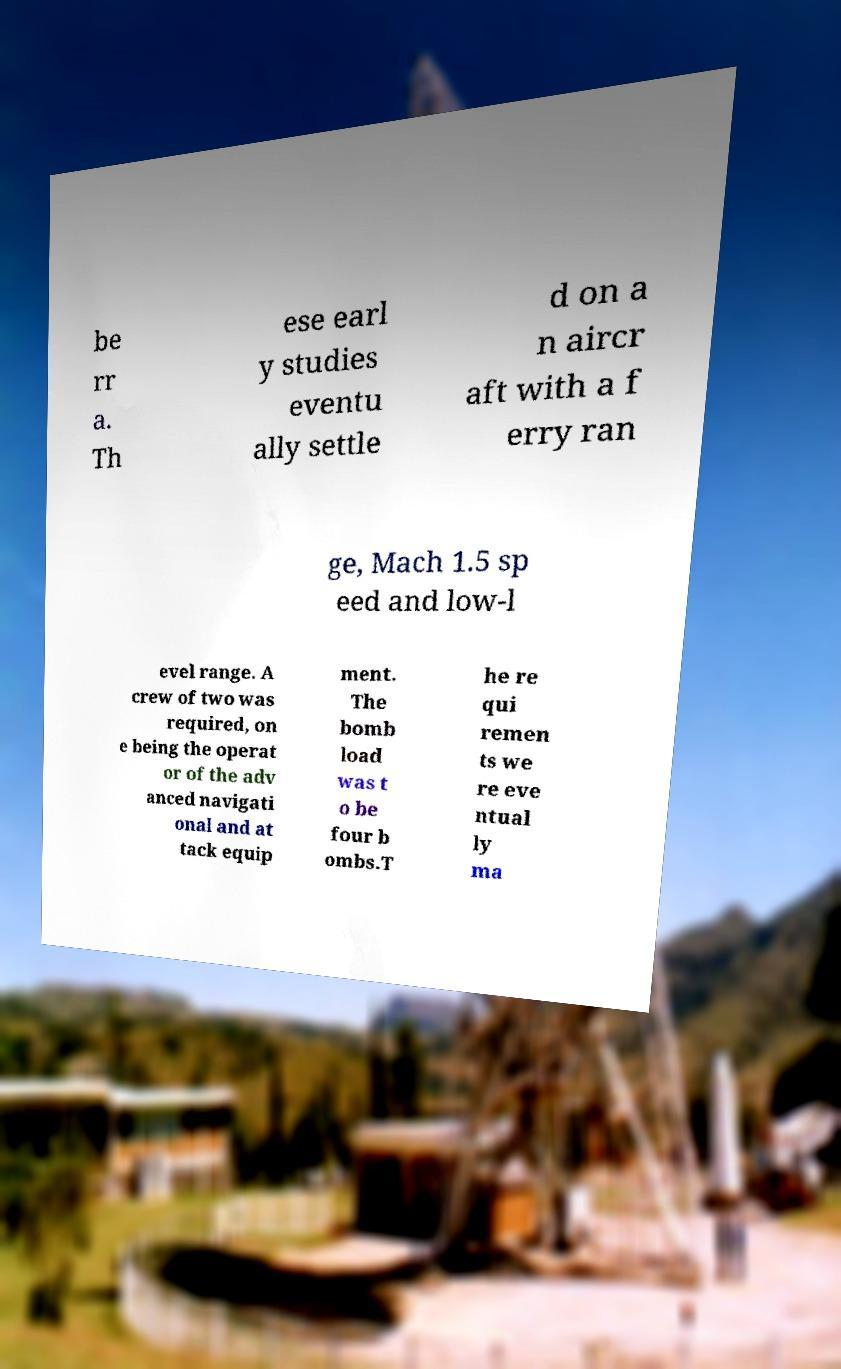Please identify and transcribe the text found in this image. be rr a. Th ese earl y studies eventu ally settle d on a n aircr aft with a f erry ran ge, Mach 1.5 sp eed and low-l evel range. A crew of two was required, on e being the operat or of the adv anced navigati onal and at tack equip ment. The bomb load was t o be four b ombs.T he re qui remen ts we re eve ntual ly ma 